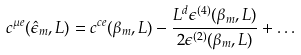<formula> <loc_0><loc_0><loc_500><loc_500>c ^ { \mu e } ( \hat { \epsilon } _ { m } , L ) = c ^ { c e } ( \beta _ { m } , L ) - \frac { L ^ { d } \epsilon ^ { ( 4 ) } ( \beta _ { m } , L ) } { 2 \epsilon ^ { ( 2 ) } ( \beta _ { m } , L ) } + \dots</formula> 